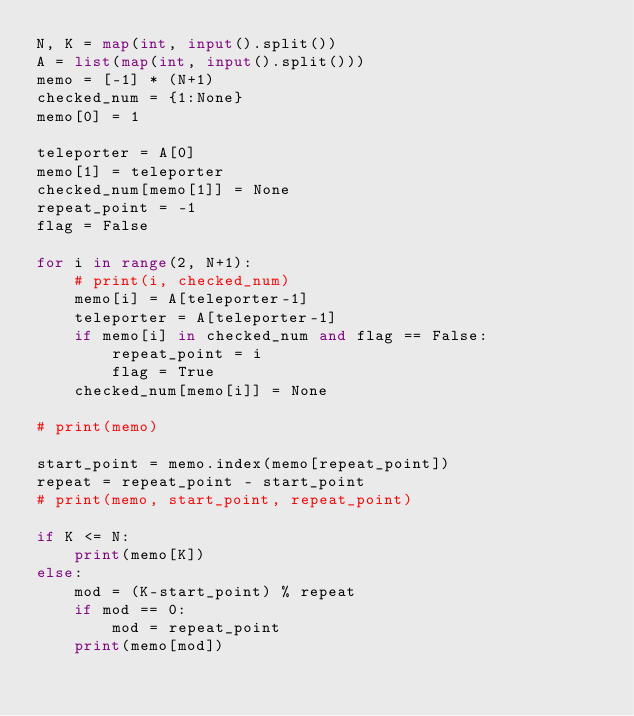Convert code to text. <code><loc_0><loc_0><loc_500><loc_500><_Python_>N, K = map(int, input().split())
A = list(map(int, input().split()))
memo = [-1] * (N+1)
checked_num = {1:None}
memo[0] = 1

teleporter = A[0]
memo[1] = teleporter
checked_num[memo[1]] = None
repeat_point = -1
flag = False

for i in range(2, N+1):
    # print(i, checked_num)
    memo[i] = A[teleporter-1]
    teleporter = A[teleporter-1]
    if memo[i] in checked_num and flag == False:
        repeat_point = i
        flag = True
    checked_num[memo[i]] = None

# print(memo)

start_point = memo.index(memo[repeat_point])
repeat = repeat_point - start_point
# print(memo, start_point, repeat_point)

if K <= N:
    print(memo[K])
else:
    mod = (K-start_point) % repeat
    if mod == 0:
        mod = repeat_point
    print(memo[mod])
</code> 